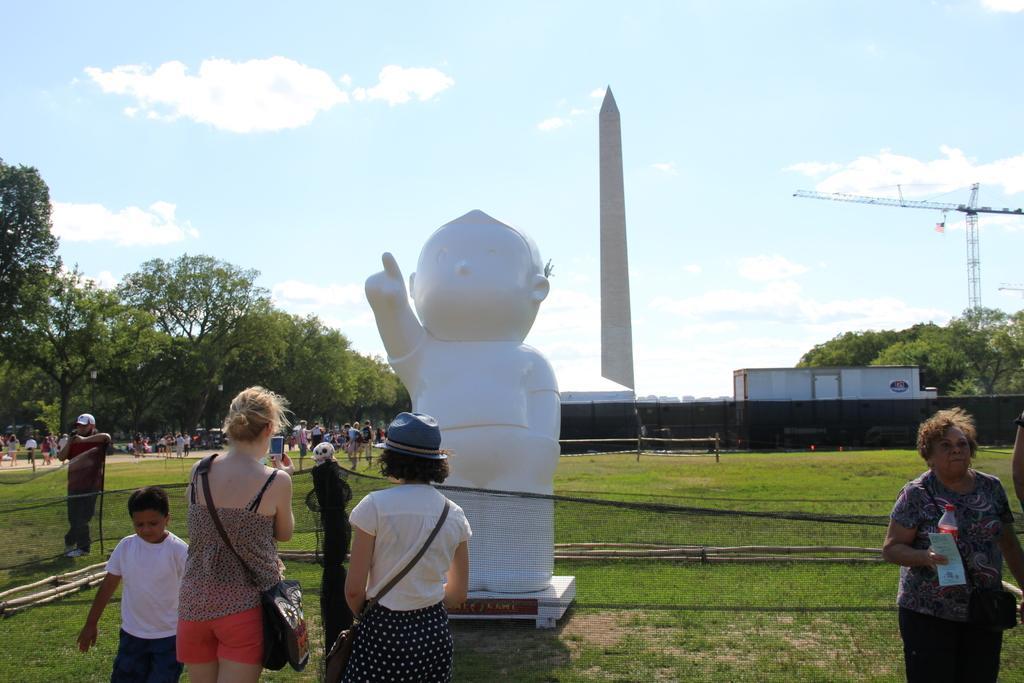How would you summarize this image in a sentence or two? This image consists of many people. At the bottom, there is green grass. In the middle, there is a statue. In the background, there are trees. 